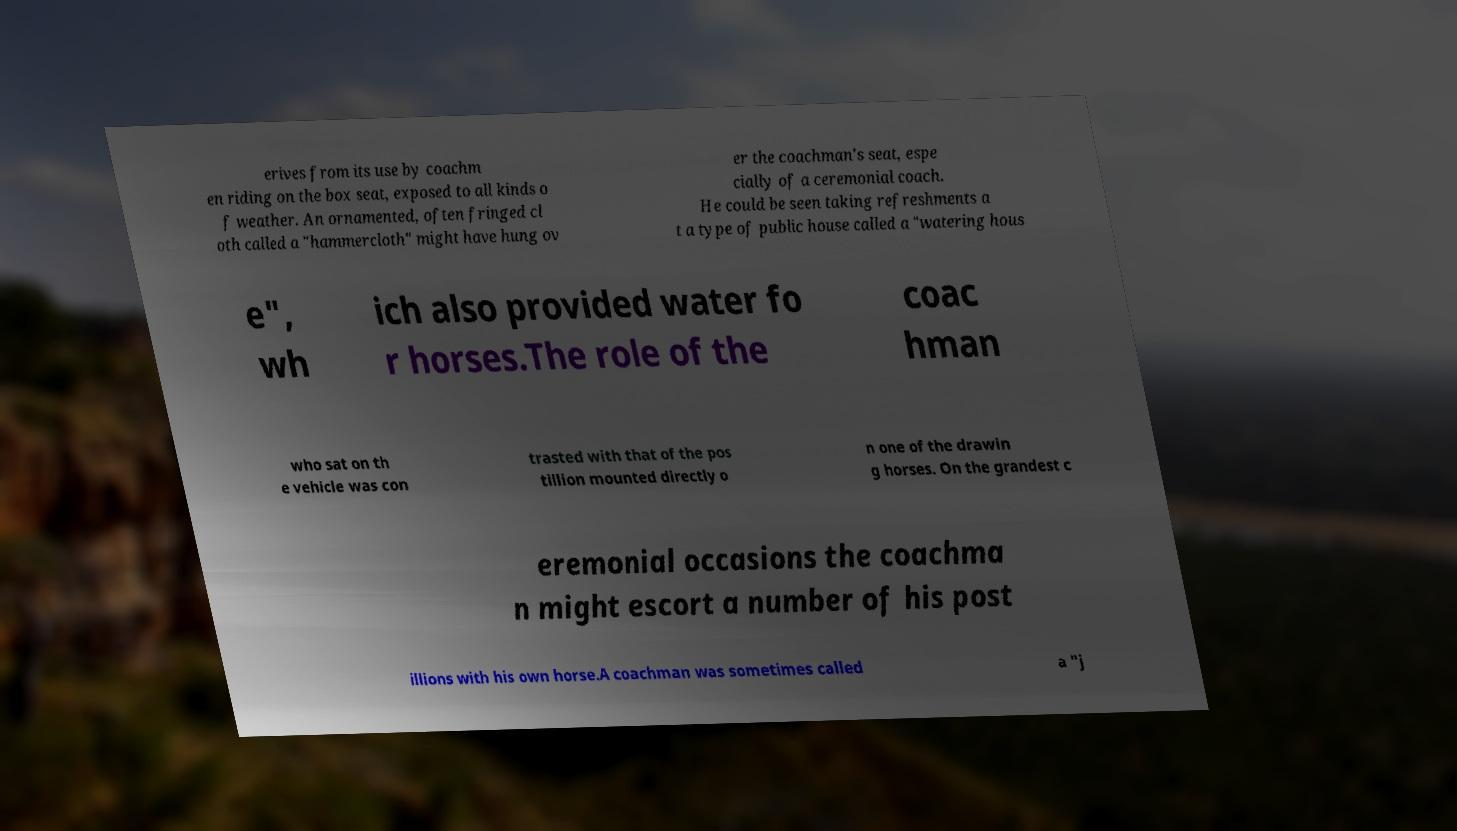There's text embedded in this image that I need extracted. Can you transcribe it verbatim? erives from its use by coachm en riding on the box seat, exposed to all kinds o f weather. An ornamented, often fringed cl oth called a "hammercloth" might have hung ov er the coachman's seat, espe cially of a ceremonial coach. He could be seen taking refreshments a t a type of public house called a "watering hous e", wh ich also provided water fo r horses.The role of the coac hman who sat on th e vehicle was con trasted with that of the pos tillion mounted directly o n one of the drawin g horses. On the grandest c eremonial occasions the coachma n might escort a number of his post illions with his own horse.A coachman was sometimes called a "j 